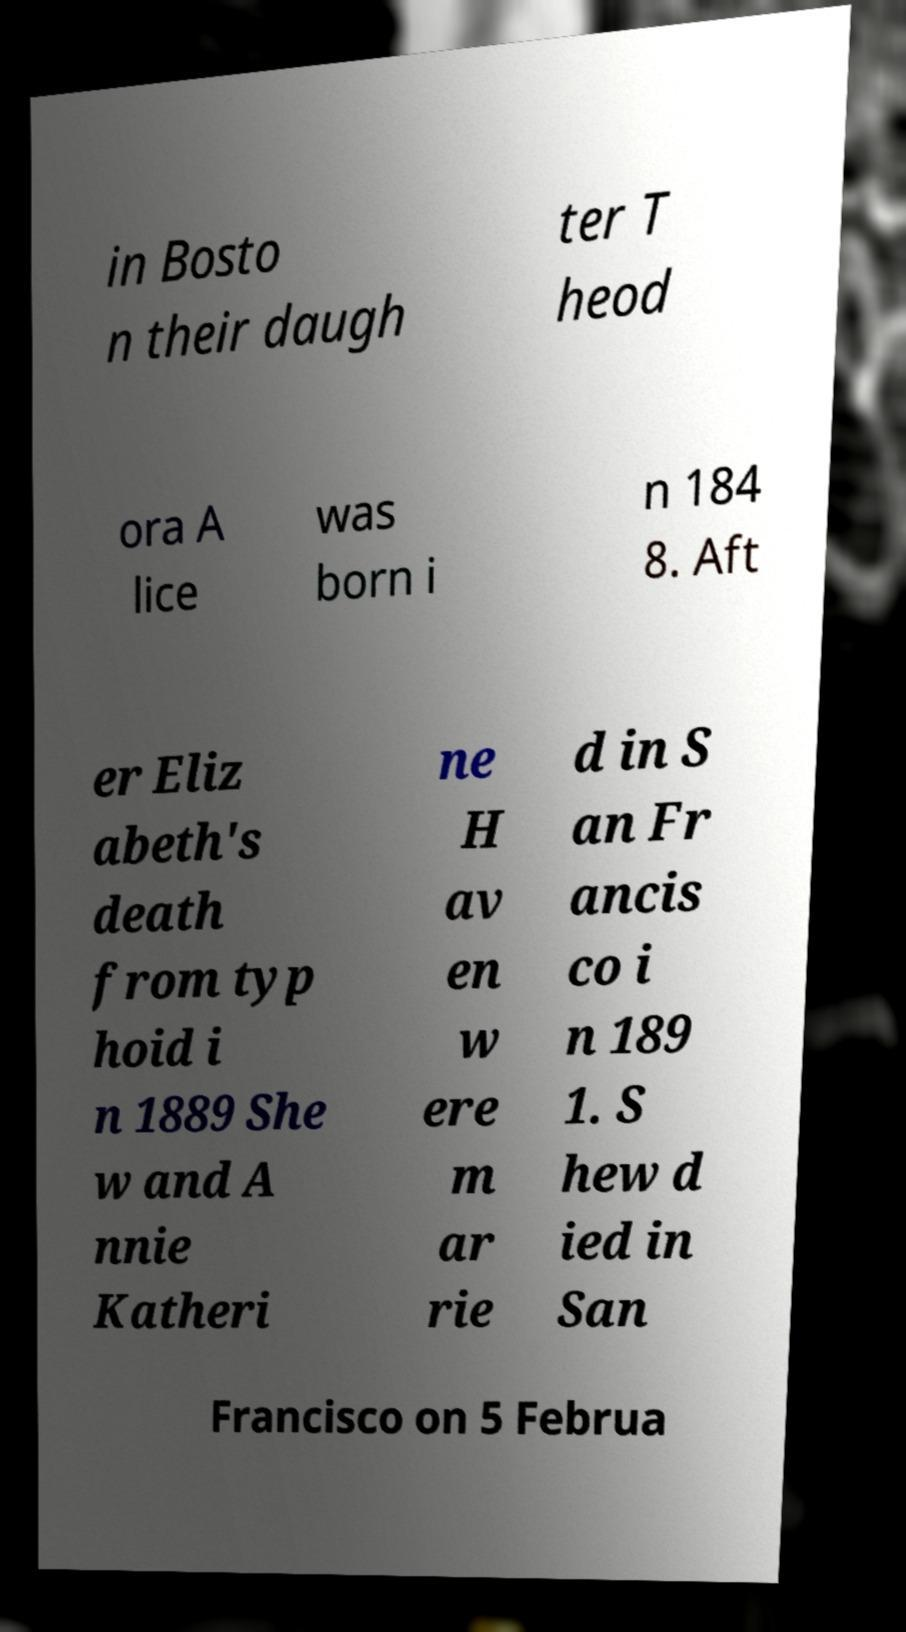For documentation purposes, I need the text within this image transcribed. Could you provide that? in Bosto n their daugh ter T heod ora A lice was born i n 184 8. Aft er Eliz abeth's death from typ hoid i n 1889 She w and A nnie Katheri ne H av en w ere m ar rie d in S an Fr ancis co i n 189 1. S hew d ied in San Francisco on 5 Februa 